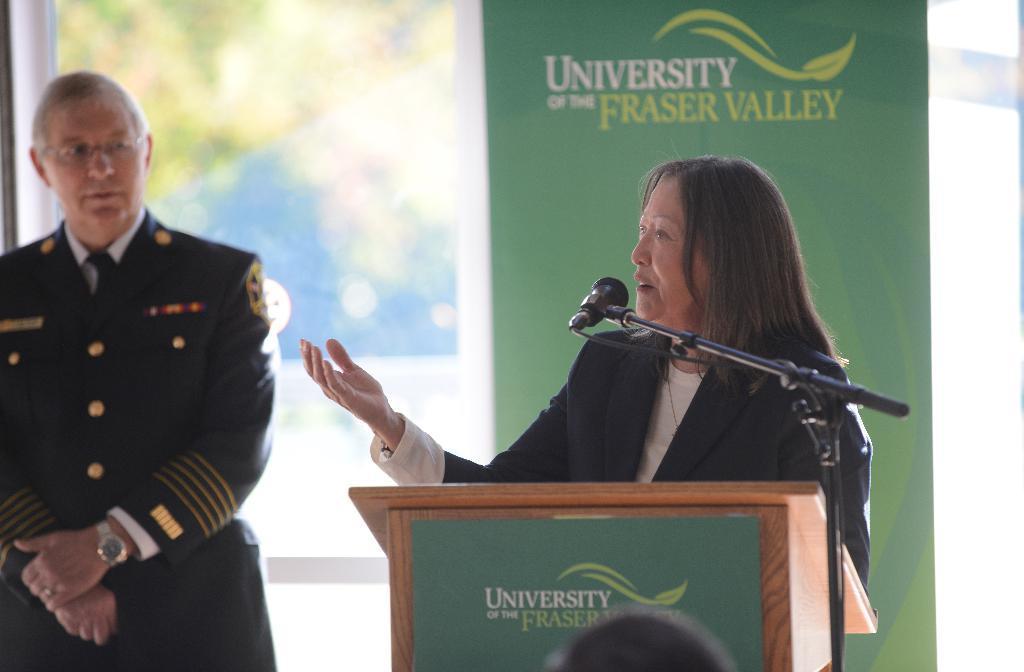Please provide a concise description of this image. On the right side there is a woman standing in front of the podium and speaking on the mike by looking at the left side. On the left side there is a man wearing uniform, standing and looking at this woman. In the background there is a glass to which a green color banner is attached. On the banner I can see some text. 